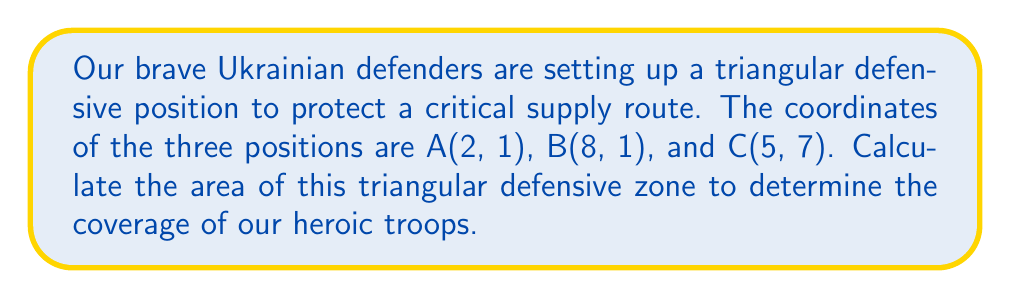Can you solve this math problem? To find the area of the triangular defensive zone, we can use the formula for the area of a triangle given the coordinates of its vertices. This method is known as the Shoelace formula or the Surveyor's formula.

Given:
- Point A: (2, 1)
- Point B: (8, 1)
- Point C: (5, 7)

The formula for the area of a triangle using coordinates is:

$$ \text{Area} = \frac{1}{2}|x_1(y_2 - y_3) + x_2(y_3 - y_1) + x_3(y_1 - y_2)| $$

Where $(x_1, y_1)$, $(x_2, y_2)$, and $(x_3, y_3)$ are the coordinates of the three vertices.

Let's substitute our values:

$$ \begin{align*}
\text{Area} &= \frac{1}{2}|2(1 - 7) + 8(7 - 1) + 5(1 - 1)| \\
&= \frac{1}{2}|2(-6) + 8(6) + 5(0)| \\
&= \frac{1}{2}|-12 + 48 + 0| \\
&= \frac{1}{2}|36| \\
&= \frac{1}{2} \cdot 36 \\
&= 18
\end{align*} $$

Therefore, the area of the triangular defensive zone is 18 square units.

[asy]
unitsize(1cm);
draw((0,0)--(10,0)--(10,8)--(0,8)--cycle);
dot((2,1),red);
dot((8,1),red);
dot((5,7),red);
draw((2,1)--(8,1)--(5,7)--cycle,blue);
label("A(2,1)",(2,1),SW,red);
label("B(8,1)",(8,1),SE,red);
label("C(5,7)",(5,7),N,red);
[/asy]
Answer: The area of the triangular defensive zone is 18 square units. 